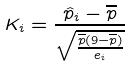Convert formula to latex. <formula><loc_0><loc_0><loc_500><loc_500>K _ { i } = \frac { \hat { p } _ { i } - \overline { p } } { \sqrt { \frac { \overline { p } ( 9 - \overline { p } ) } { e _ { i } } } }</formula> 